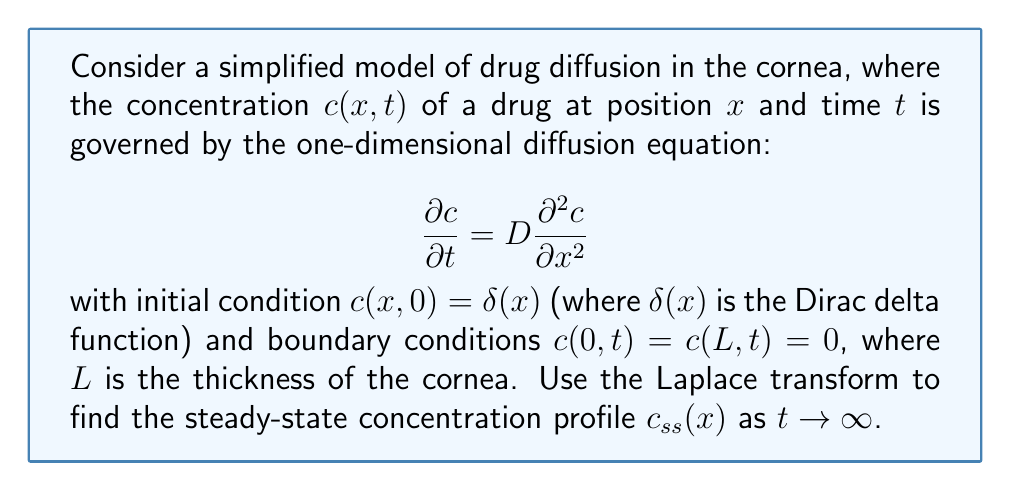Solve this math problem. To solve this problem, we'll use the Laplace transform with respect to time. Let's denote the Laplace transform of $c(x,t)$ as $C(x,s)$.

1) Take the Laplace transform of the diffusion equation:

   $$\mathcal{L}\left\{\frac{\partial c}{\partial t}\right\} = D\mathcal{L}\left\{\frac{\partial^2 c}{\partial x^2}\right\}$$

   $$sC(x,s) - c(x,0) = D\frac{d^2C(x,s)}{dx^2}$$

2) Substitute the initial condition:

   $$sC(x,s) - \delta(x) = D\frac{d^2C(x,s)}{dx^2}$$

3) Rearrange:

   $$\frac{d^2C(x,s)}{dx^2} - \frac{s}{D}C(x,s) = -\frac{\delta(x)}{D}$$

4) This is an inhomogeneous second-order ODE. Its general solution is:

   $$C(x,s) = A\sinh(\sqrt{\frac{s}{D}}x) + B\cosh(\sqrt{\frac{s}{D}}x) + \frac{1}{2s\sqrt{D/s}}\exp(-\sqrt{\frac{s}{D}}|x|)$$

5) Apply the boundary conditions in the s-domain:

   $C(0,s) = C(L,s) = 0$

6) This gives us:

   $$B = -\frac{1}{2s\sqrt{D/s}}$$
   $$A\sinh(\sqrt{\frac{s}{D}}L) + B\cosh(\sqrt{\frac{s}{D}}L) + \frac{1}{2s\sqrt{D/s}}\exp(-\sqrt{\frac{s}{D}}L) = 0$$

7) Solve for A and substitute back into the general solution.

8) To find the steady-state solution, we need to apply the final value theorem:

   $$c_{ss}(x) = \lim_{t\to\infty} c(x,t) = \lim_{s\to0} sC(x,s)$$

9) Taking the limit as $s \to 0$, we get:

   $$c_{ss}(x) = \frac{x(L-x)}{2DL}$$

This is the steady-state concentration profile.
Answer: The steady-state concentration profile is:

$$c_{ss}(x) = \frac{x(L-x)}{2DL}$$

where $x$ is the position in the cornea, $L$ is the thickness of the cornea, and $D$ is the diffusion coefficient. 